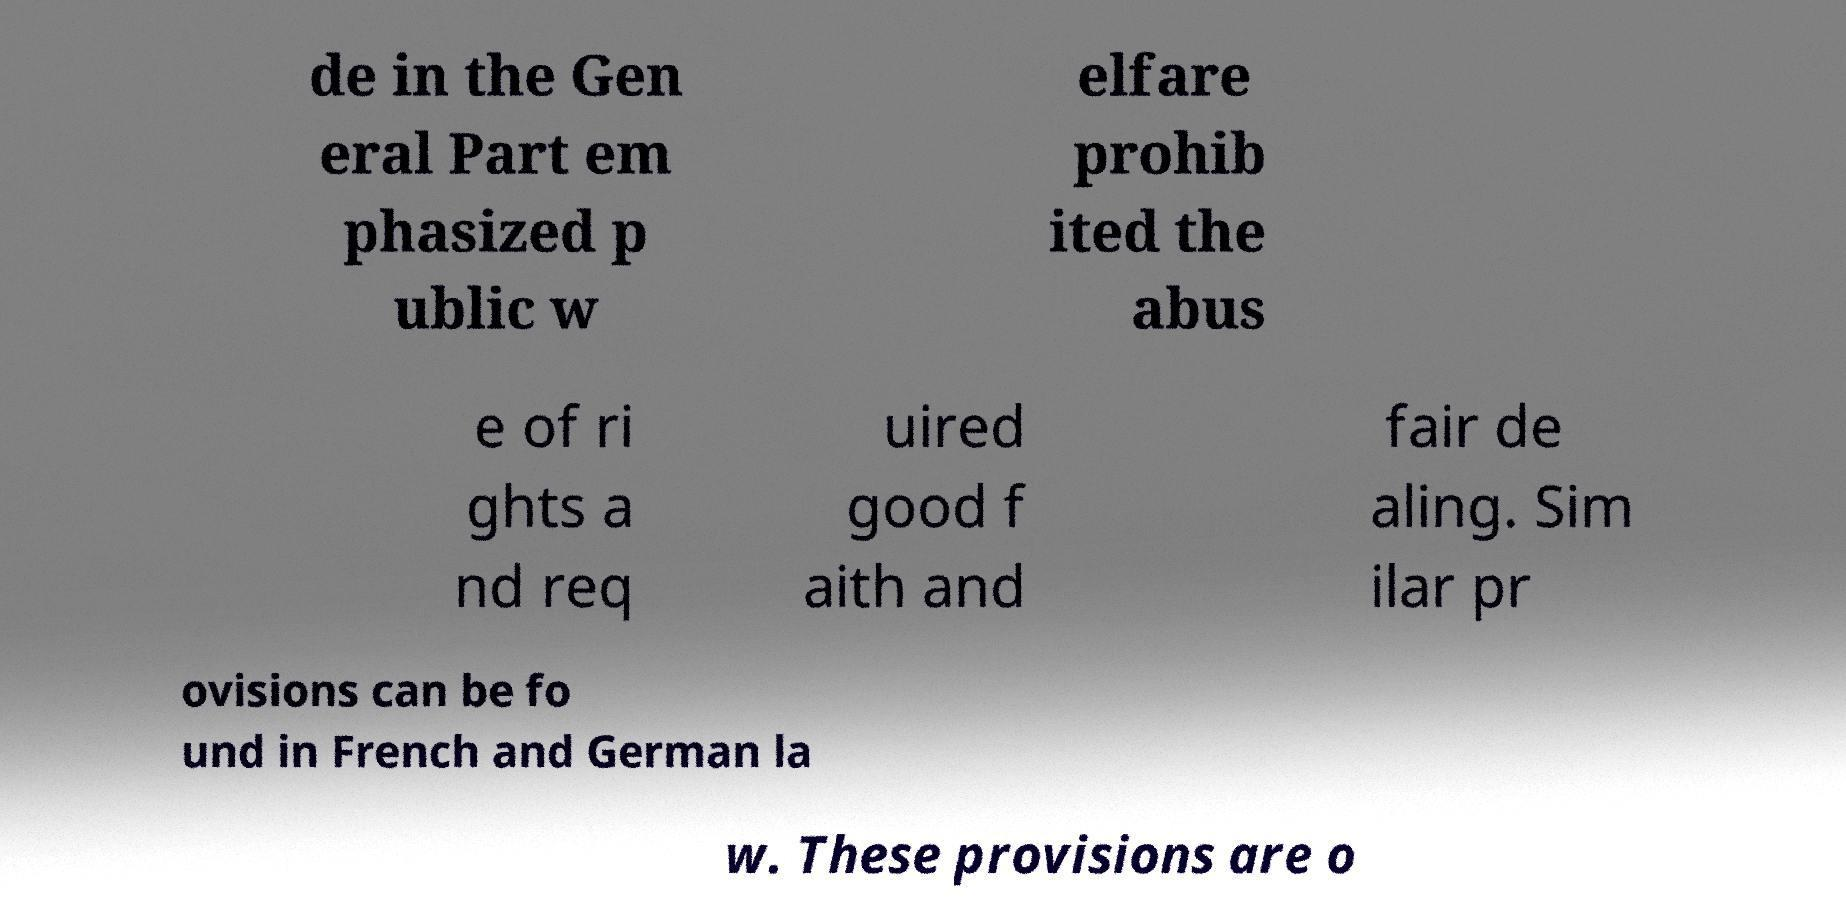Please read and relay the text visible in this image. What does it say? de in the Gen eral Part em phasized p ublic w elfare prohib ited the abus e of ri ghts a nd req uired good f aith and fair de aling. Sim ilar pr ovisions can be fo und in French and German la w. These provisions are o 